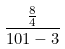Convert formula to latex. <formula><loc_0><loc_0><loc_500><loc_500>\frac { \frac { 8 } { 4 } } { 1 0 1 - 3 }</formula> 